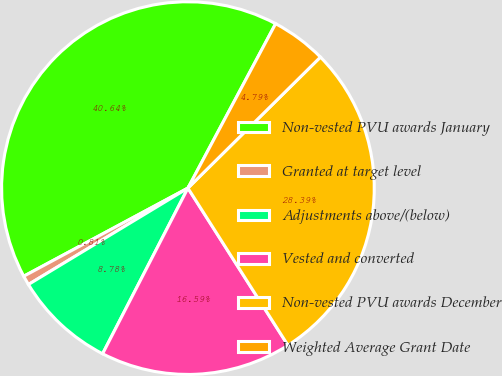<chart> <loc_0><loc_0><loc_500><loc_500><pie_chart><fcel>Non-vested PVU awards January<fcel>Granted at target level<fcel>Adjustments above/(below)<fcel>Vested and converted<fcel>Non-vested PVU awards December<fcel>Weighted Average Grant Date<nl><fcel>40.64%<fcel>0.81%<fcel>8.78%<fcel>16.59%<fcel>28.39%<fcel>4.79%<nl></chart> 